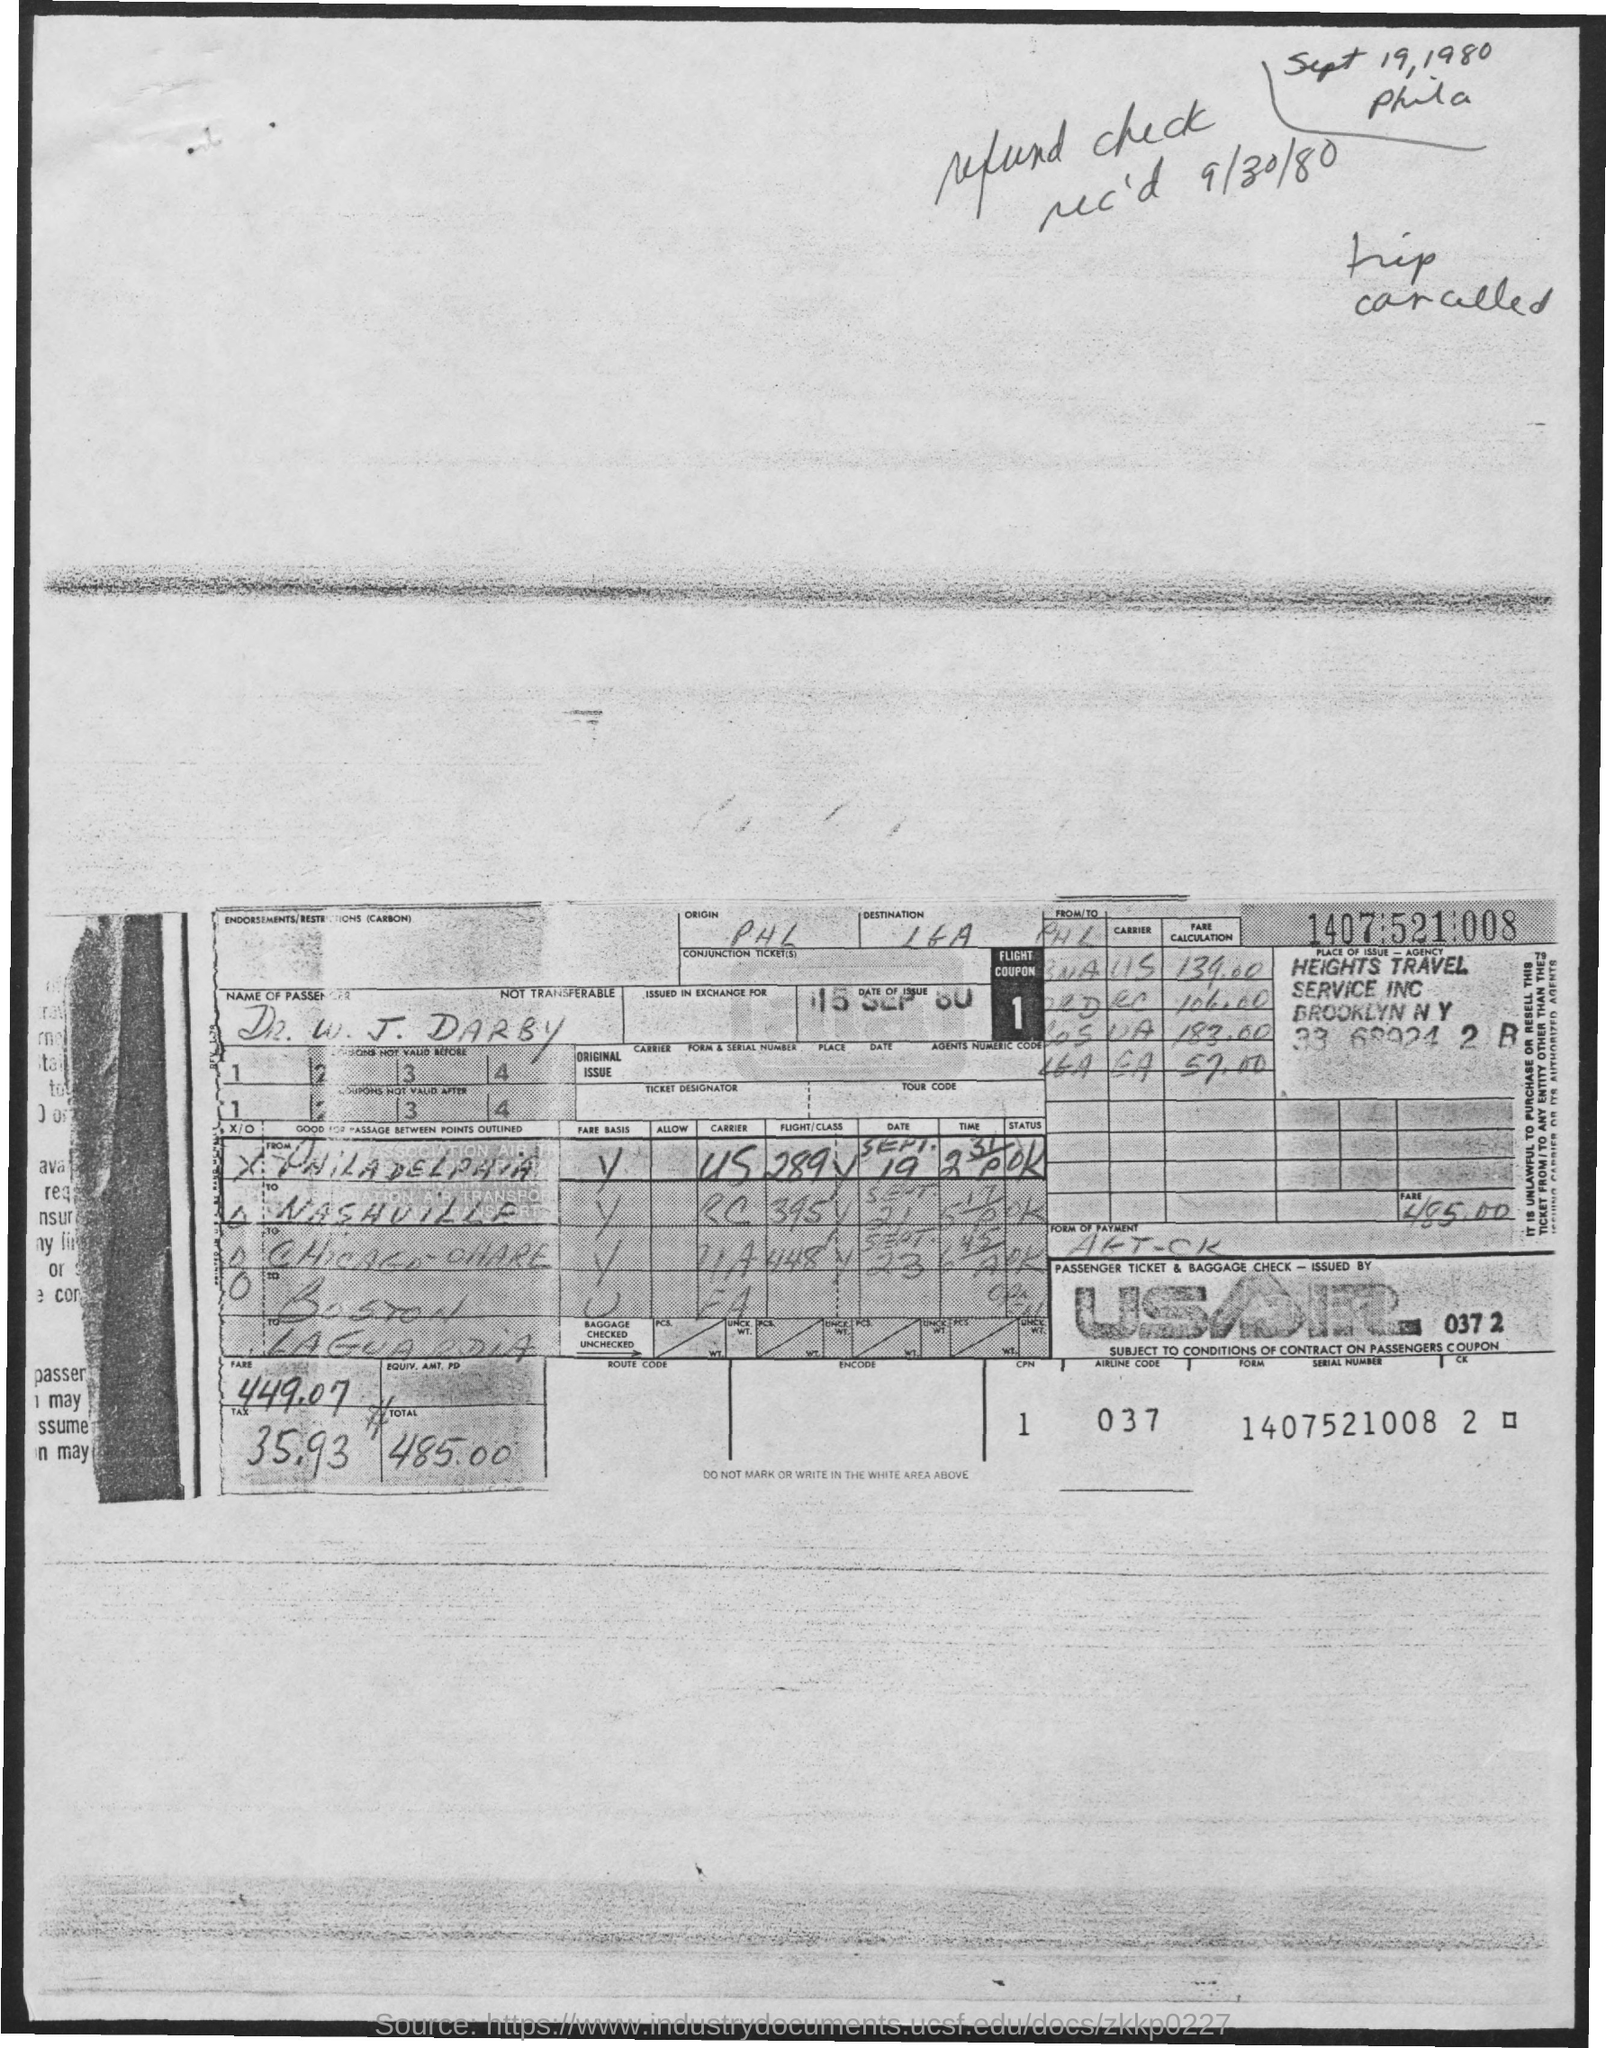Outline some significant characteristics in this image. The airline code mentioned in the given form is 037.. The total fare mentioned on the given page is 485.00. The person referred to as "W. J. DARBY" in the provided page is a passenger. The tax amount mentioned in the given form is 35.93.. The date of issue mentioned in the given form is September 15, 1980. 